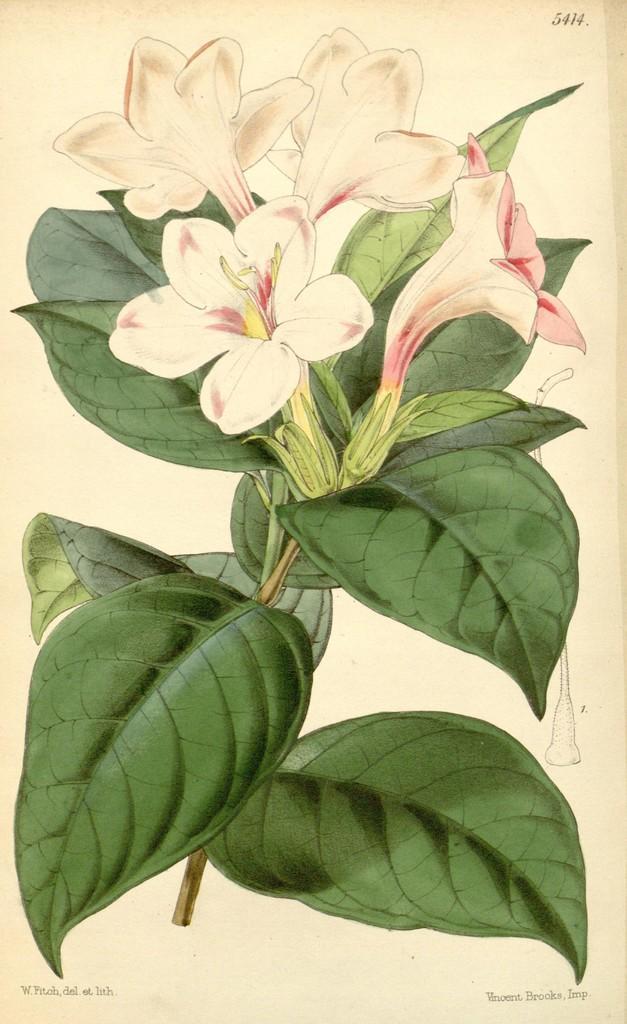Please provide a concise description of this image. In this image there is a painting of flowers and green leaves. 